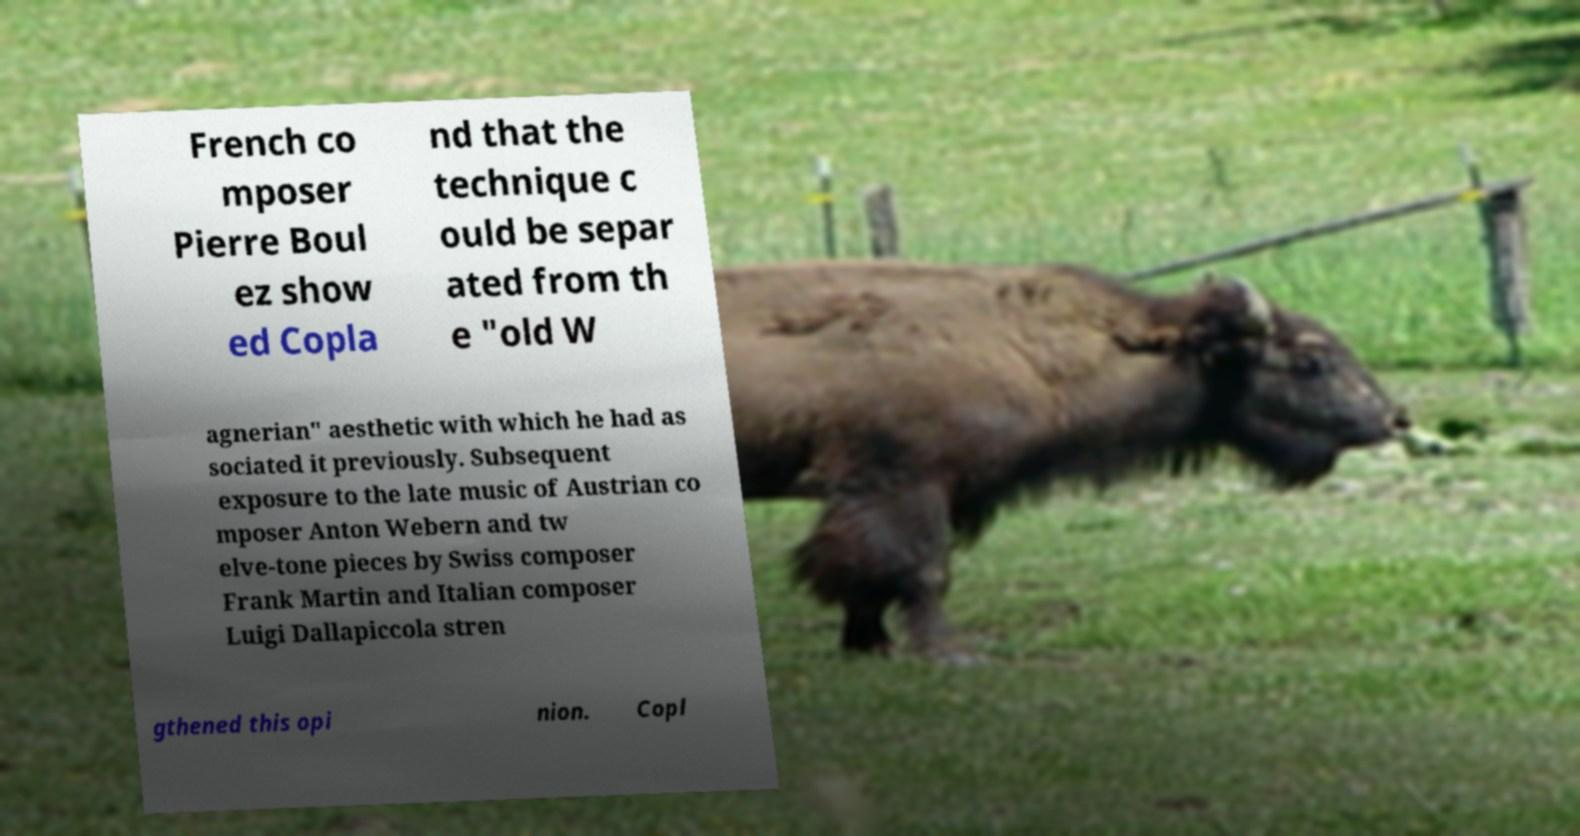Please identify and transcribe the text found in this image. French co mposer Pierre Boul ez show ed Copla nd that the technique c ould be separ ated from th e "old W agnerian" aesthetic with which he had as sociated it previously. Subsequent exposure to the late music of Austrian co mposer Anton Webern and tw elve-tone pieces by Swiss composer Frank Martin and Italian composer Luigi Dallapiccola stren gthened this opi nion. Copl 